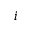Convert formula to latex. <formula><loc_0><loc_0><loc_500><loc_500>i</formula> 